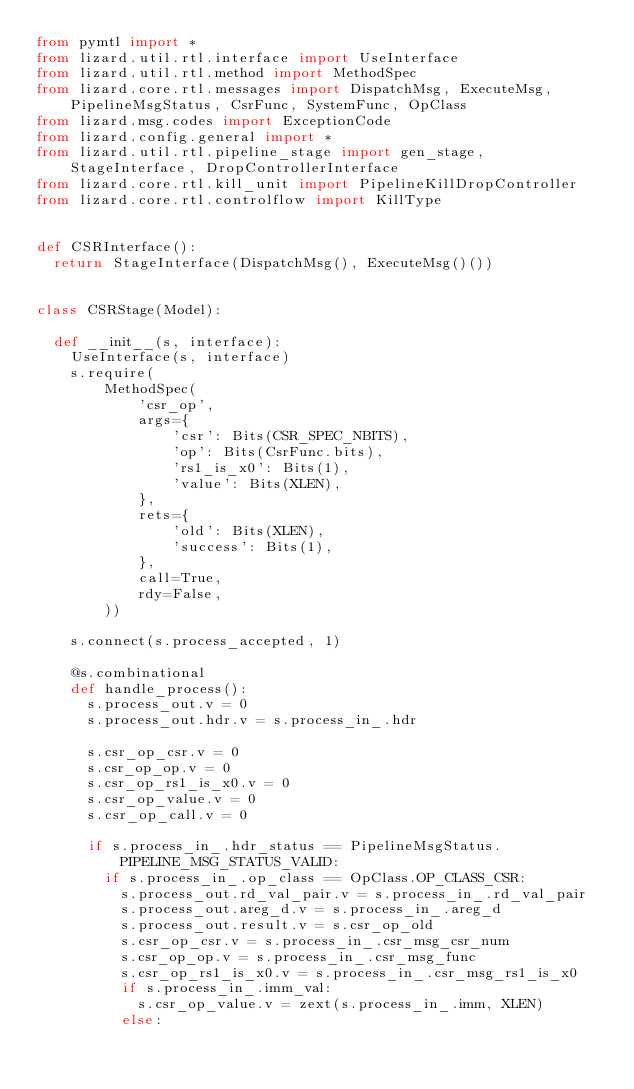<code> <loc_0><loc_0><loc_500><loc_500><_Python_>from pymtl import *
from lizard.util.rtl.interface import UseInterface
from lizard.util.rtl.method import MethodSpec
from lizard.core.rtl.messages import DispatchMsg, ExecuteMsg, PipelineMsgStatus, CsrFunc, SystemFunc, OpClass
from lizard.msg.codes import ExceptionCode
from lizard.config.general import *
from lizard.util.rtl.pipeline_stage import gen_stage, StageInterface, DropControllerInterface
from lizard.core.rtl.kill_unit import PipelineKillDropController
from lizard.core.rtl.controlflow import KillType


def CSRInterface():
  return StageInterface(DispatchMsg(), ExecuteMsg()())


class CSRStage(Model):

  def __init__(s, interface):
    UseInterface(s, interface)
    s.require(
        MethodSpec(
            'csr_op',
            args={
                'csr': Bits(CSR_SPEC_NBITS),
                'op': Bits(CsrFunc.bits),
                'rs1_is_x0': Bits(1),
                'value': Bits(XLEN),
            },
            rets={
                'old': Bits(XLEN),
                'success': Bits(1),
            },
            call=True,
            rdy=False,
        ))

    s.connect(s.process_accepted, 1)

    @s.combinational
    def handle_process():
      s.process_out.v = 0
      s.process_out.hdr.v = s.process_in_.hdr

      s.csr_op_csr.v = 0
      s.csr_op_op.v = 0
      s.csr_op_rs1_is_x0.v = 0
      s.csr_op_value.v = 0
      s.csr_op_call.v = 0

      if s.process_in_.hdr_status == PipelineMsgStatus.PIPELINE_MSG_STATUS_VALID:
        if s.process_in_.op_class == OpClass.OP_CLASS_CSR:
          s.process_out.rd_val_pair.v = s.process_in_.rd_val_pair
          s.process_out.areg_d.v = s.process_in_.areg_d
          s.process_out.result.v = s.csr_op_old
          s.csr_op_csr.v = s.process_in_.csr_msg_csr_num
          s.csr_op_op.v = s.process_in_.csr_msg_func
          s.csr_op_rs1_is_x0.v = s.process_in_.csr_msg_rs1_is_x0
          if s.process_in_.imm_val:
            s.csr_op_value.v = zext(s.process_in_.imm, XLEN)
          else:</code> 